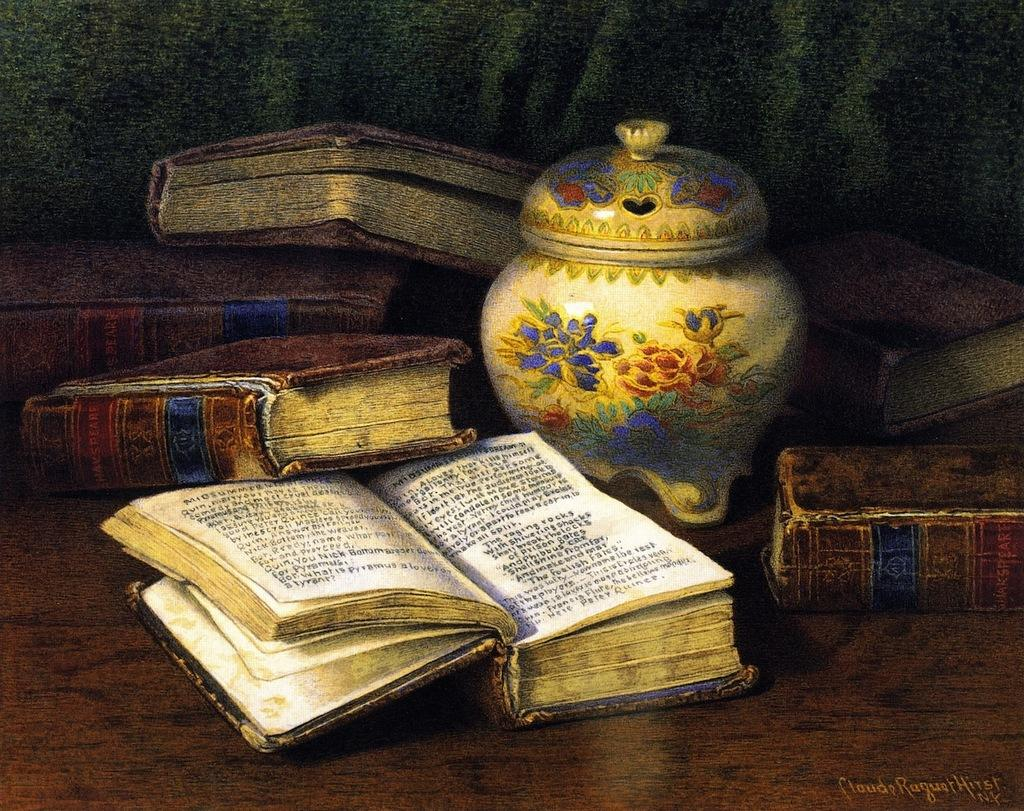What type of artwork is depicted in the image? The image is a painting. What objects can be seen in the painting? There are books and a ceramic pot with a lid in the painting. Is there any indication of who created the painting? Yes, there is a signature in the painting. Can you tell me how many boats are in the stream depicted in the painting? There is no stream or boat present in the painting; it features books and a ceramic pot with a lid. 